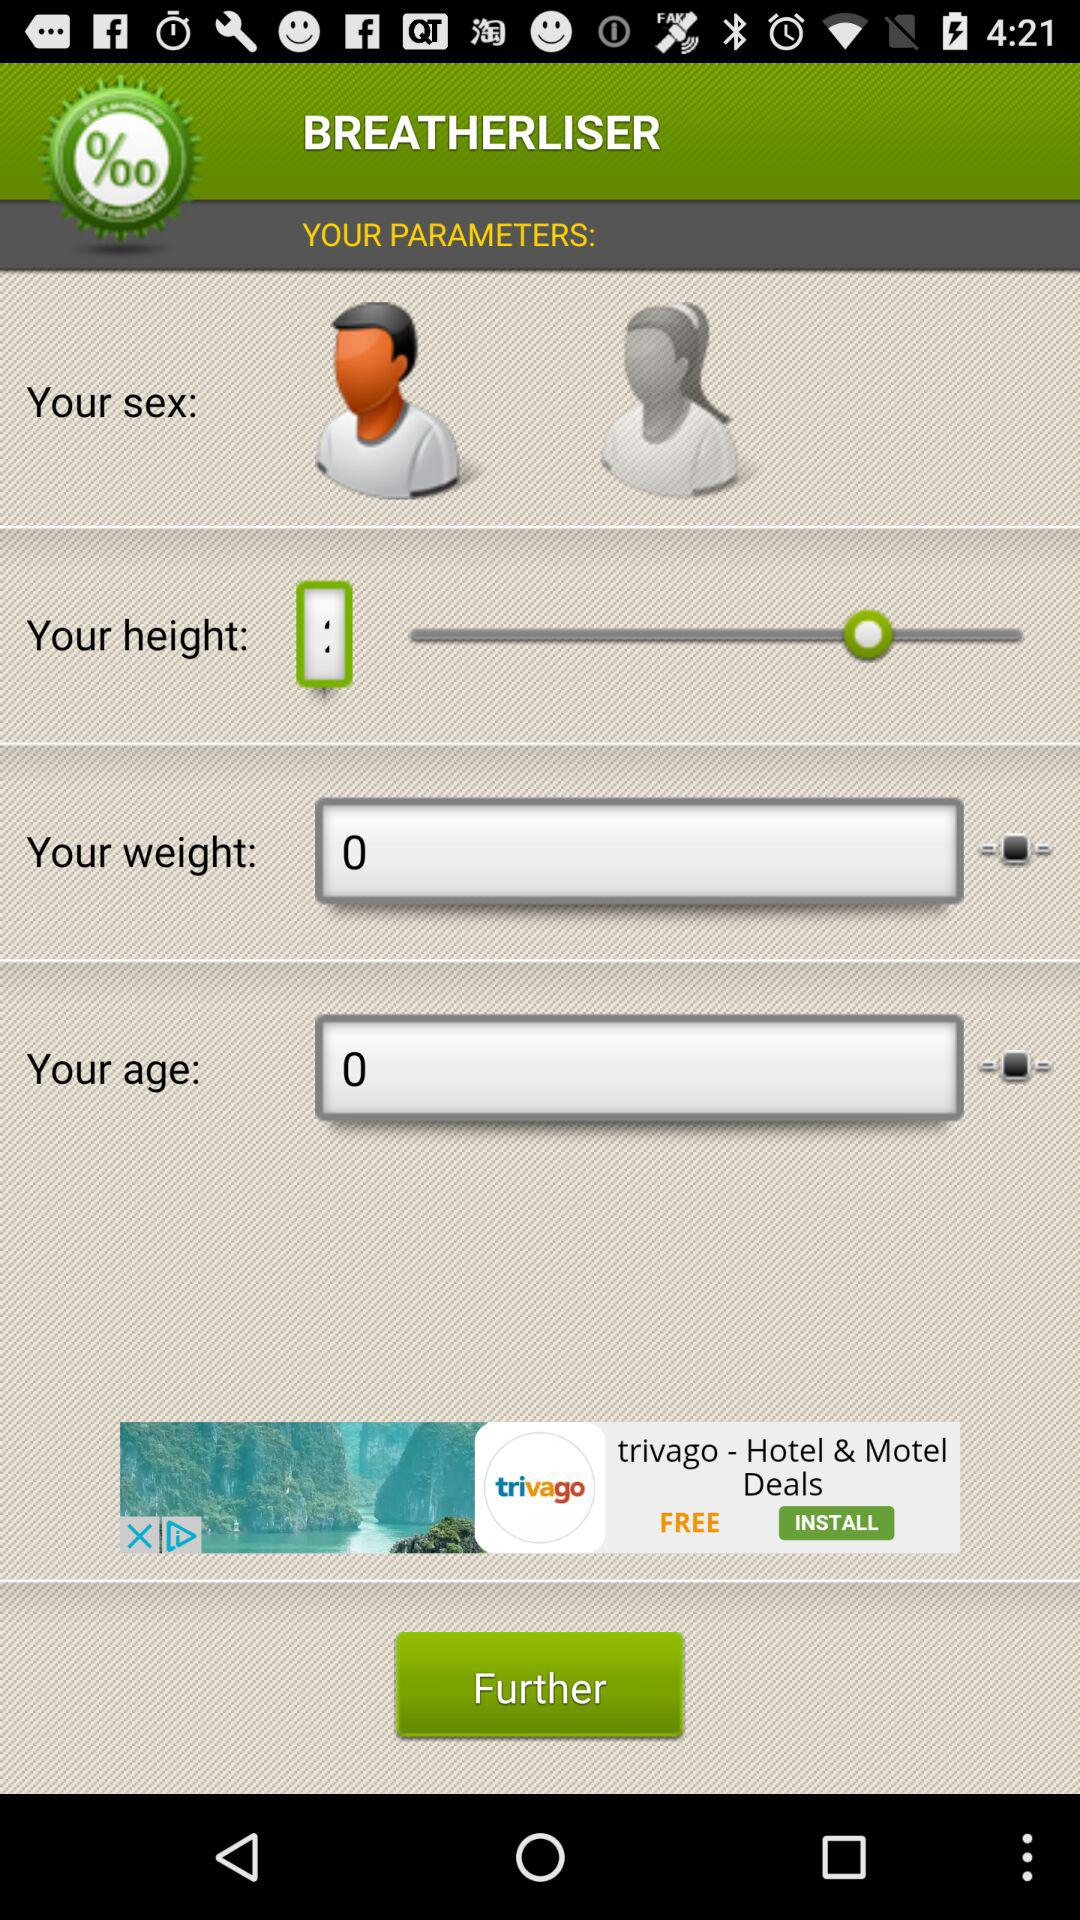What is the name of the application? The name of the application is "BREATHERLISER". 